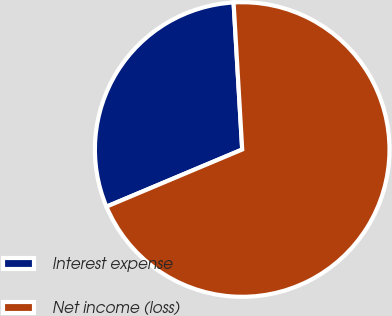Convert chart to OTSL. <chart><loc_0><loc_0><loc_500><loc_500><pie_chart><fcel>Interest expense<fcel>Net income (loss)<nl><fcel>30.41%<fcel>69.59%<nl></chart> 